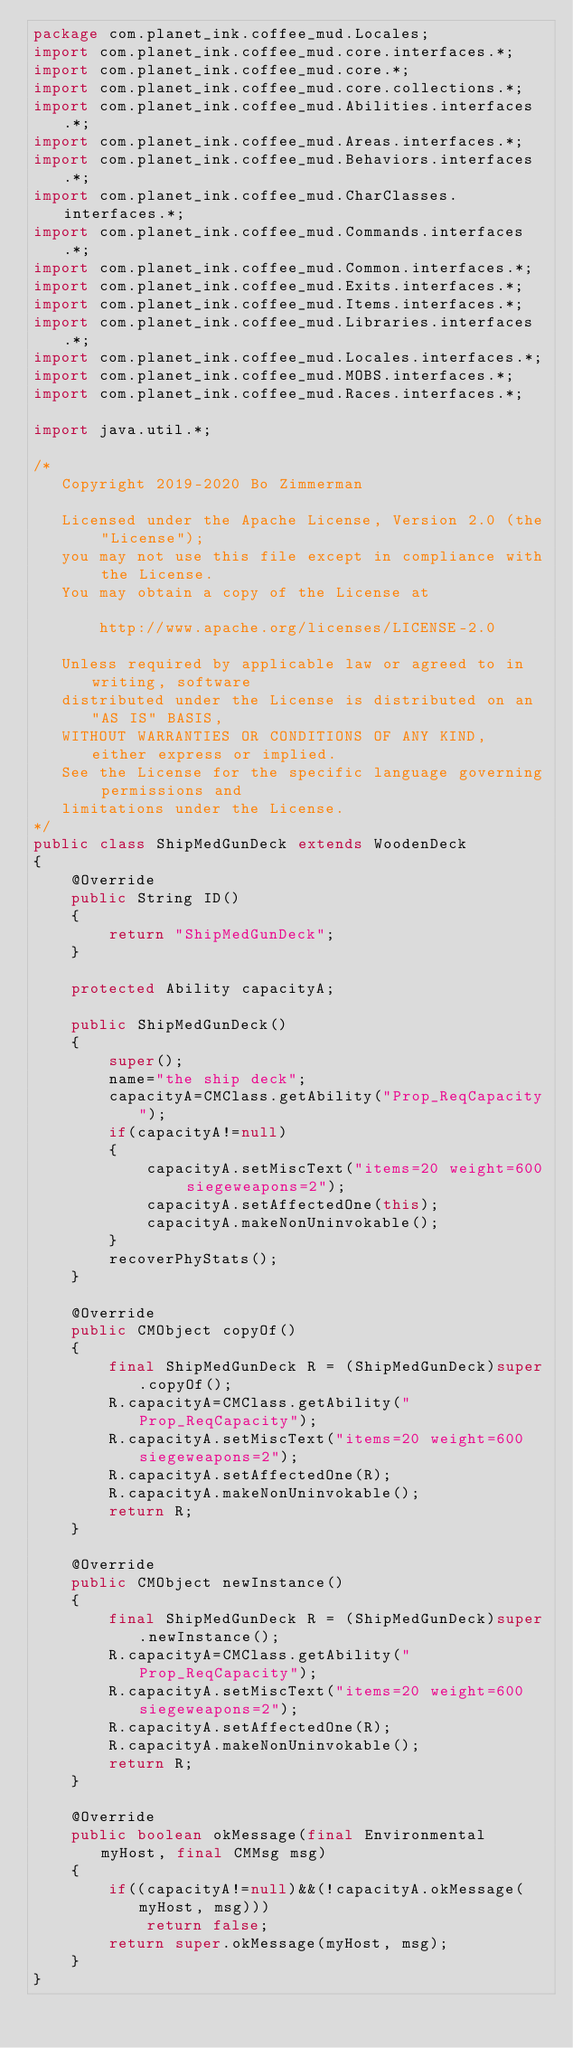Convert code to text. <code><loc_0><loc_0><loc_500><loc_500><_Java_>package com.planet_ink.coffee_mud.Locales;
import com.planet_ink.coffee_mud.core.interfaces.*;
import com.planet_ink.coffee_mud.core.*;
import com.planet_ink.coffee_mud.core.collections.*;
import com.planet_ink.coffee_mud.Abilities.interfaces.*;
import com.planet_ink.coffee_mud.Areas.interfaces.*;
import com.planet_ink.coffee_mud.Behaviors.interfaces.*;
import com.planet_ink.coffee_mud.CharClasses.interfaces.*;
import com.planet_ink.coffee_mud.Commands.interfaces.*;
import com.planet_ink.coffee_mud.Common.interfaces.*;
import com.planet_ink.coffee_mud.Exits.interfaces.*;
import com.planet_ink.coffee_mud.Items.interfaces.*;
import com.planet_ink.coffee_mud.Libraries.interfaces.*;
import com.planet_ink.coffee_mud.Locales.interfaces.*;
import com.planet_ink.coffee_mud.MOBS.interfaces.*;
import com.planet_ink.coffee_mud.Races.interfaces.*;

import java.util.*;

/*
   Copyright 2019-2020 Bo Zimmerman

   Licensed under the Apache License, Version 2.0 (the "License");
   you may not use this file except in compliance with the License.
   You may obtain a copy of the License at

	   http://www.apache.org/licenses/LICENSE-2.0

   Unless required by applicable law or agreed to in writing, software
   distributed under the License is distributed on an "AS IS" BASIS,
   WITHOUT WARRANTIES OR CONDITIONS OF ANY KIND, either express or implied.
   See the License for the specific language governing permissions and
   limitations under the License.
*/
public class ShipMedGunDeck extends WoodenDeck
{
	@Override
	public String ID()
	{
		return "ShipMedGunDeck";
	}

	protected Ability capacityA;

	public ShipMedGunDeck()
	{
		super();
		name="the ship deck";
		capacityA=CMClass.getAbility("Prop_ReqCapacity");
		if(capacityA!=null)
		{
			capacityA.setMiscText("items=20 weight=600 siegeweapons=2");
			capacityA.setAffectedOne(this);
			capacityA.makeNonUninvokable();
		}
		recoverPhyStats();
	}

	@Override
	public CMObject copyOf()
	{
		final ShipMedGunDeck R = (ShipMedGunDeck)super.copyOf();
		R.capacityA=CMClass.getAbility("Prop_ReqCapacity");
		R.capacityA.setMiscText("items=20 weight=600 siegeweapons=2");
		R.capacityA.setAffectedOne(R);
		R.capacityA.makeNonUninvokable();
		return R;
	}

	@Override
	public CMObject newInstance()
	{
		final ShipMedGunDeck R = (ShipMedGunDeck)super.newInstance();
		R.capacityA=CMClass.getAbility("Prop_ReqCapacity");
		R.capacityA.setMiscText("items=20 weight=600 siegeweapons=2");
		R.capacityA.setAffectedOne(R);
		R.capacityA.makeNonUninvokable();
		return R;
	}

	@Override
	public boolean okMessage(final Environmental myHost, final CMMsg msg)
	{
		if((capacityA!=null)&&(!capacityA.okMessage(myHost, msg)))
			return false;
		return super.okMessage(myHost, msg);
	}
}
</code> 